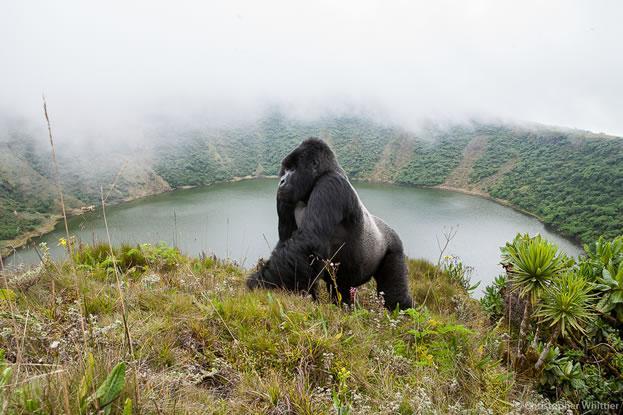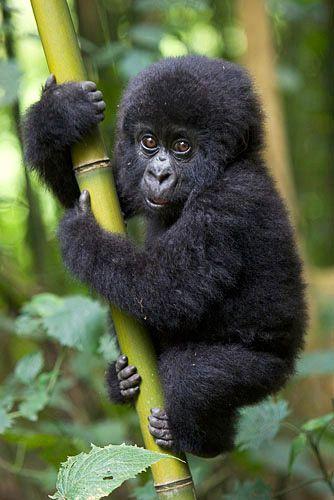The first image is the image on the left, the second image is the image on the right. For the images displayed, is the sentence "there is a long silverback gorilla on a hilltop overlooking a pool of water with fog" factually correct? Answer yes or no. Yes. 